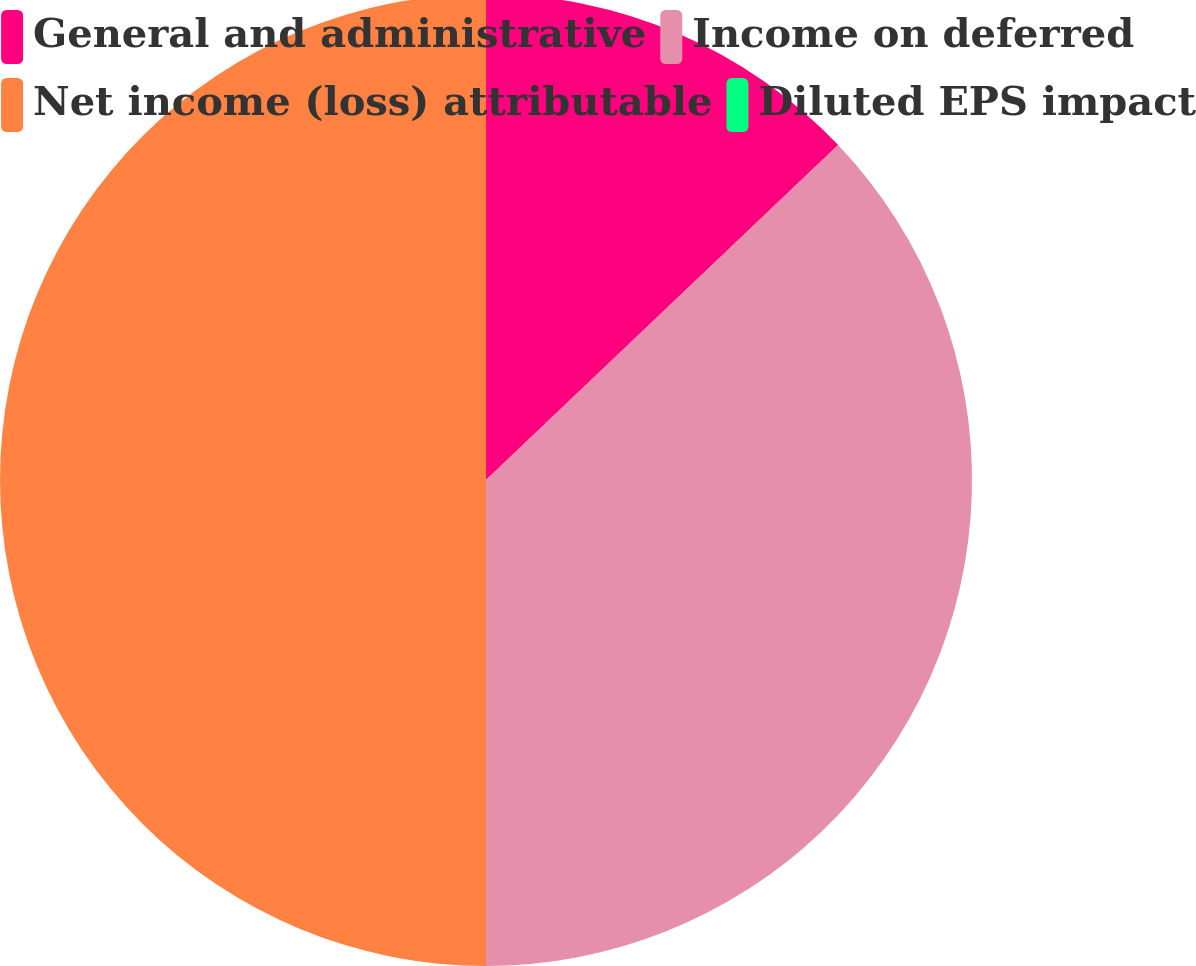Convert chart. <chart><loc_0><loc_0><loc_500><loc_500><pie_chart><fcel>General and administrative<fcel>Income on deferred<fcel>Net income (loss) attributable<fcel>Diluted EPS impact<nl><fcel>12.9%<fcel>37.1%<fcel>50.0%<fcel>0.0%<nl></chart> 